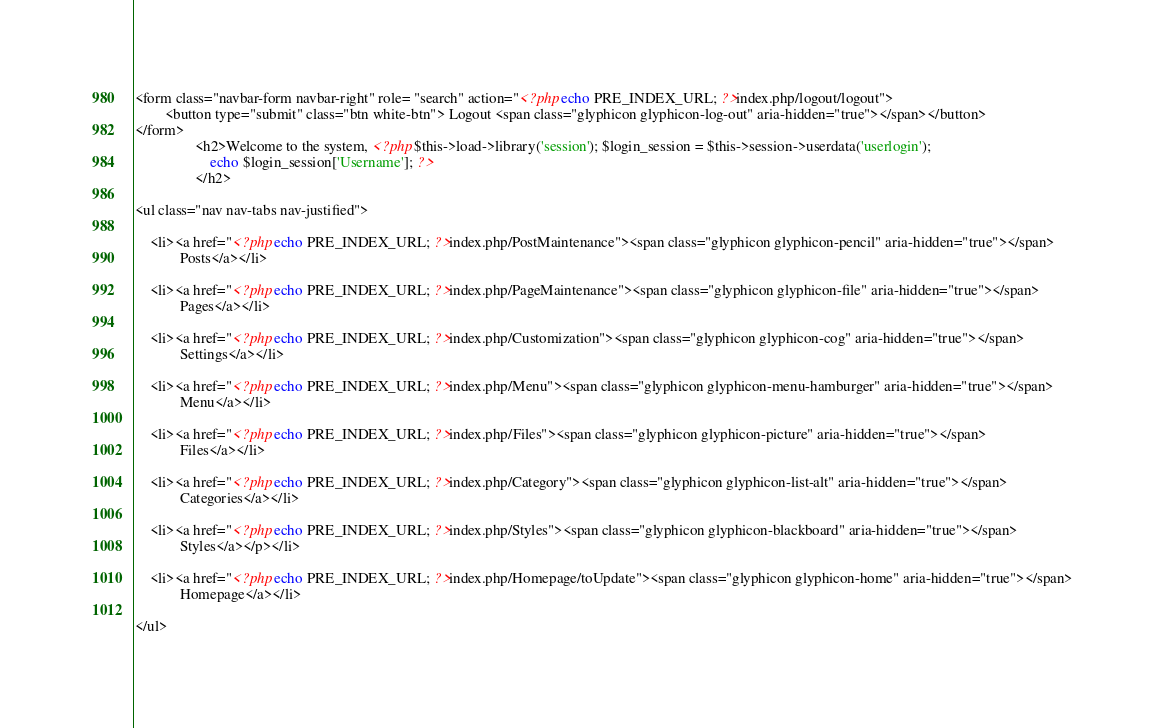<code> <loc_0><loc_0><loc_500><loc_500><_PHP_><form class="navbar-form navbar-right" role= "search" action="<?php echo PRE_INDEX_URL; ?>index.php/logout/logout"> 
        <button type="submit" class="btn white-btn"> Logout <span class="glyphicon glyphicon-log-out" aria-hidden="true"></span></button> 
</form> 
                <h2>Welcome to the system, <?php $this->load->library('session'); $login_session = $this->session->userdata('userlogin'); 
                    echo $login_session['Username']; ?> 
                </h2>

<ul class="nav nav-tabs nav-justified">  
  
    <li><a href="<?php echo PRE_INDEX_URL; ?>index.php/PostMaintenance"><span class="glyphicon glyphicon-pencil" aria-hidden="true"></span>
            Posts</a></li>    
    
    <li><a href="<?php echo PRE_INDEX_URL; ?>index.php/PageMaintenance"><span class="glyphicon glyphicon-file" aria-hidden="true"></span>
            Pages</a></li>
   
    <li><a href="<?php echo PRE_INDEX_URL; ?>index.php/Customization"><span class="glyphicon glyphicon-cog" aria-hidden="true"></span>
            Settings</a></li> 
    
    <li><a href="<?php echo PRE_INDEX_URL; ?>index.php/Menu"><span class="glyphicon glyphicon-menu-hamburger" aria-hidden="true"></span>
            Menu</a></li>
    
    <li><a href="<?php echo PRE_INDEX_URL; ?>index.php/Files"><span class="glyphicon glyphicon-picture" aria-hidden="true"></span>
            Files</a></li>
    
    <li><a href="<?php echo PRE_INDEX_URL; ?>index.php/Category"><span class="glyphicon glyphicon-list-alt" aria-hidden="true"></span>
            Categories</a></li>
    
    <li><a href="<?php echo PRE_INDEX_URL; ?>index.php/Styles"><span class="glyphicon glyphicon-blackboard" aria-hidden="true"></span>
            Styles</a></p></li>
    
    <li><a href="<?php echo PRE_INDEX_URL; ?>index.php/Homepage/toUpdate"><span class="glyphicon glyphicon-home" aria-hidden="true"></span>
            Homepage</a></li>
    
</ul>
</code> 